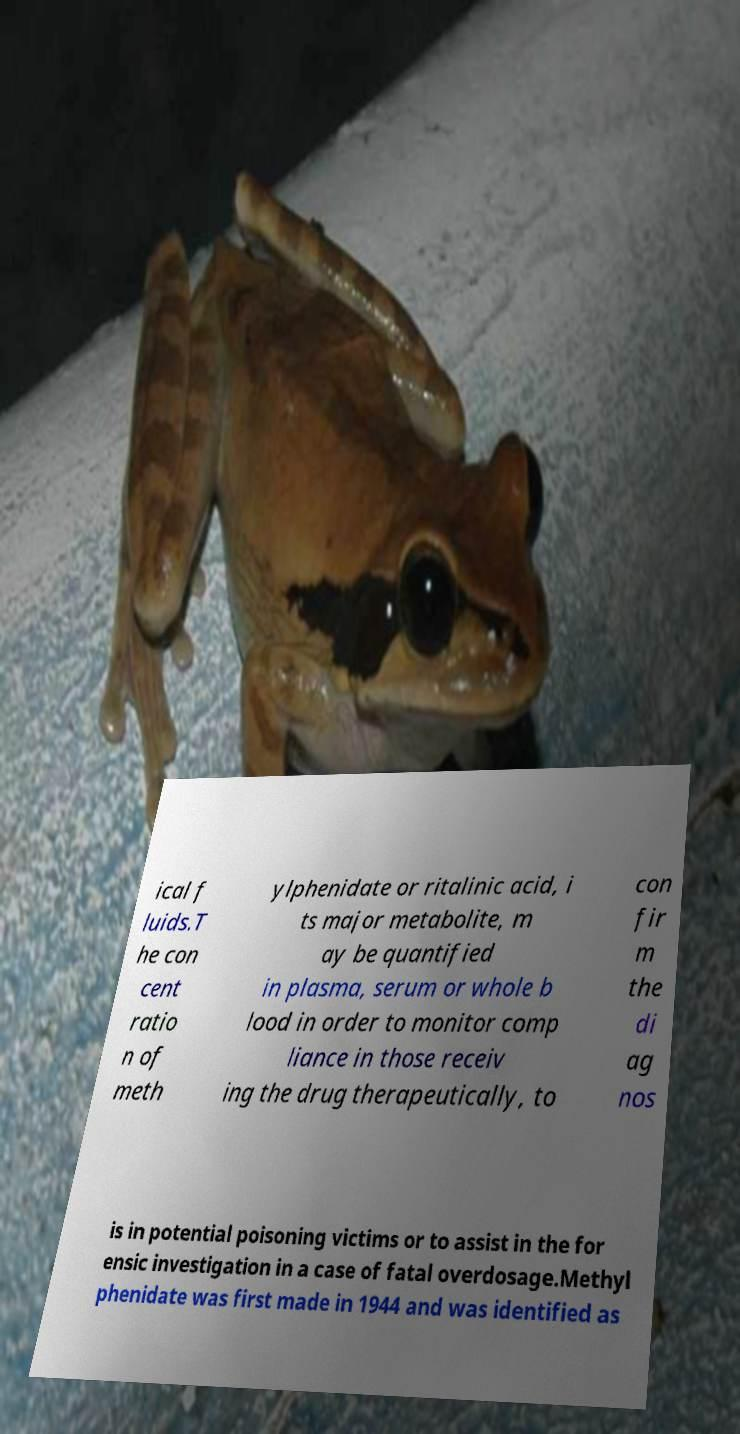What messages or text are displayed in this image? I need them in a readable, typed format. ical f luids.T he con cent ratio n of meth ylphenidate or ritalinic acid, i ts major metabolite, m ay be quantified in plasma, serum or whole b lood in order to monitor comp liance in those receiv ing the drug therapeutically, to con fir m the di ag nos is in potential poisoning victims or to assist in the for ensic investigation in a case of fatal overdosage.Methyl phenidate was first made in 1944 and was identified as 